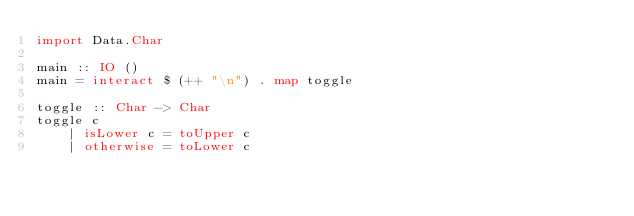Convert code to text. <code><loc_0><loc_0><loc_500><loc_500><_Haskell_>import Data.Char

main :: IO ()
main = interact $ (++ "\n") . map toggle

toggle :: Char -> Char
toggle c
    | isLower c = toUpper c
    | otherwise = toLower c
</code> 